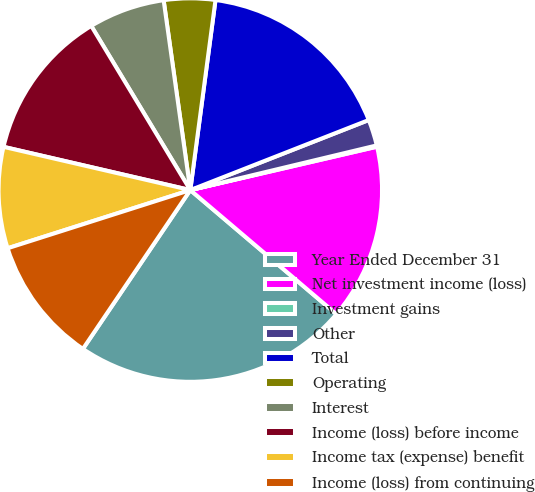Convert chart. <chart><loc_0><loc_0><loc_500><loc_500><pie_chart><fcel>Year Ended December 31<fcel>Net investment income (loss)<fcel>Investment gains<fcel>Other<fcel>Total<fcel>Operating<fcel>Interest<fcel>Income (loss) before income<fcel>Income tax (expense) benefit<fcel>Income (loss) from continuing<nl><fcel>23.26%<fcel>14.84%<fcel>0.11%<fcel>2.21%<fcel>16.95%<fcel>4.32%<fcel>6.42%<fcel>12.74%<fcel>8.53%<fcel>10.63%<nl></chart> 